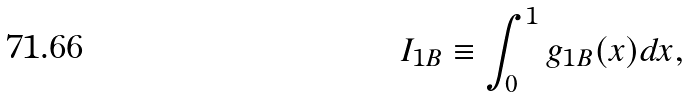<formula> <loc_0><loc_0><loc_500><loc_500>I _ { 1 B } \equiv \int _ { 0 } ^ { 1 } g _ { 1 B } ( x ) d x ,</formula> 